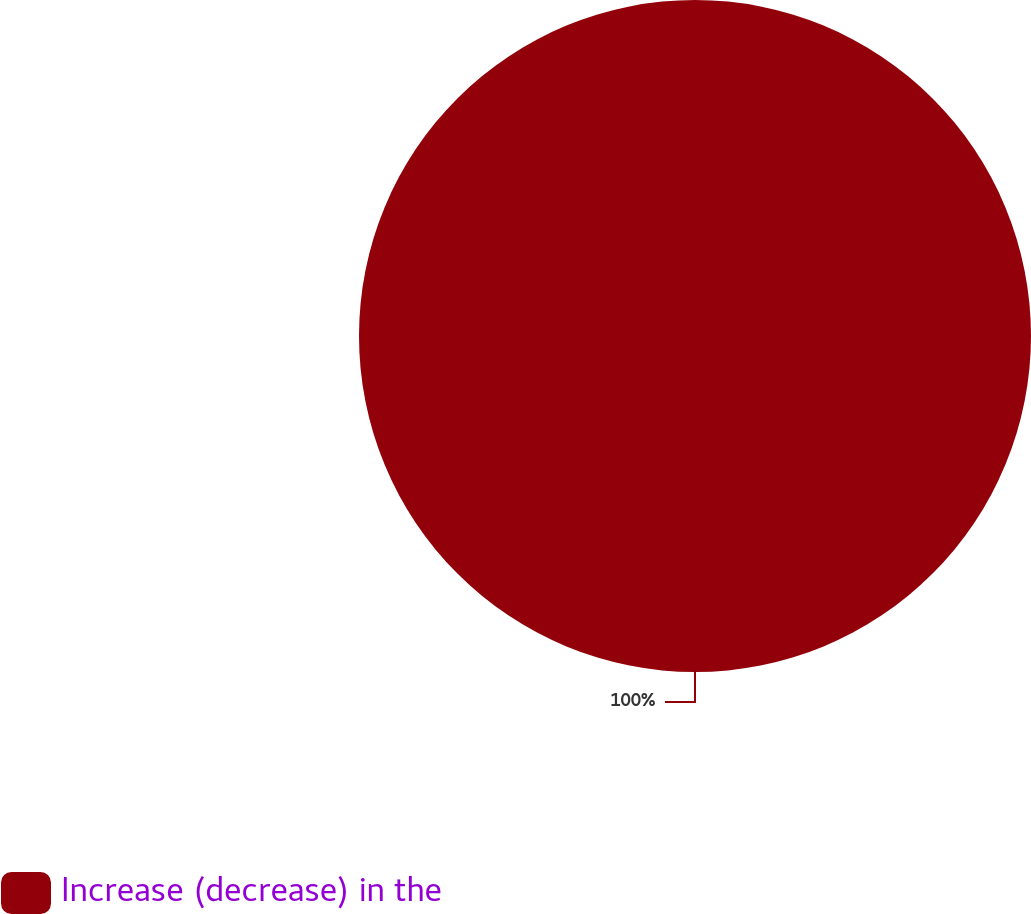<chart> <loc_0><loc_0><loc_500><loc_500><pie_chart><fcel>Increase (decrease) in the<nl><fcel>100.0%<nl></chart> 